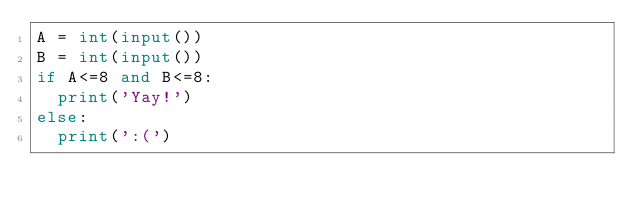<code> <loc_0><loc_0><loc_500><loc_500><_Python_>A = int(input())
B = int(input())
if A<=8 and B<=8:
  print('Yay!')
else:
  print(':(')</code> 